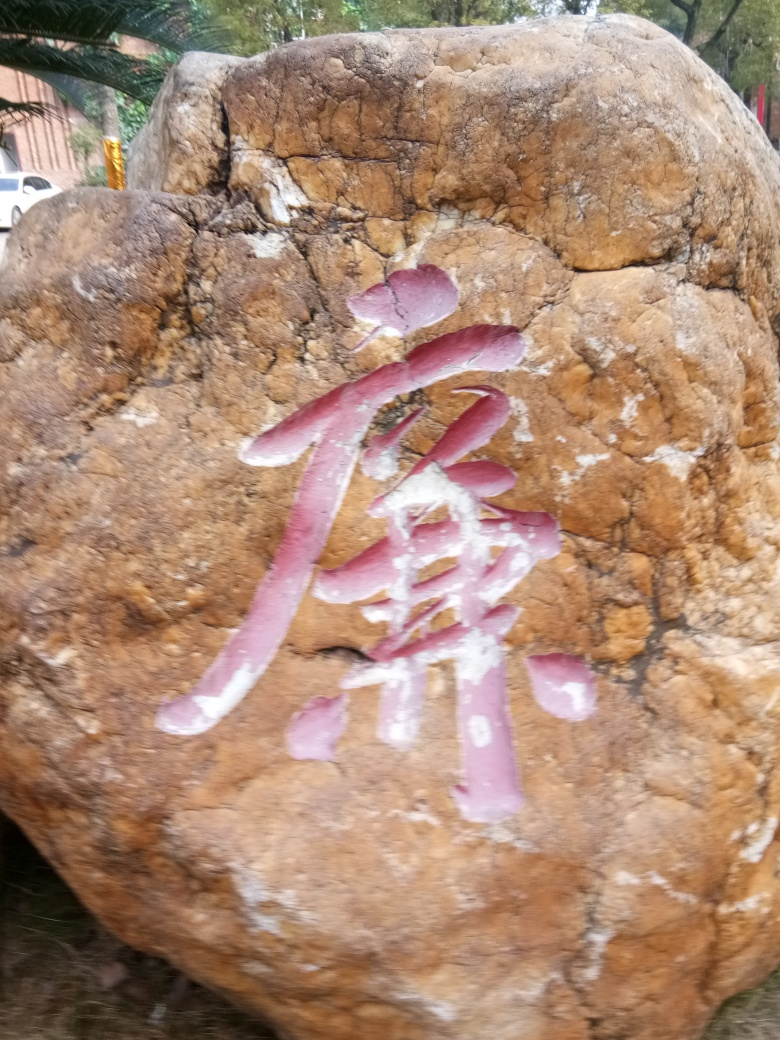Are there any quality issues with this image? The image is slightly out of focus, and the lighting conditions could be better to enhance visibility. Additionally, there is visible noise, and the angle of the shot might not be ideal to fully appreciate the details on the rock. 